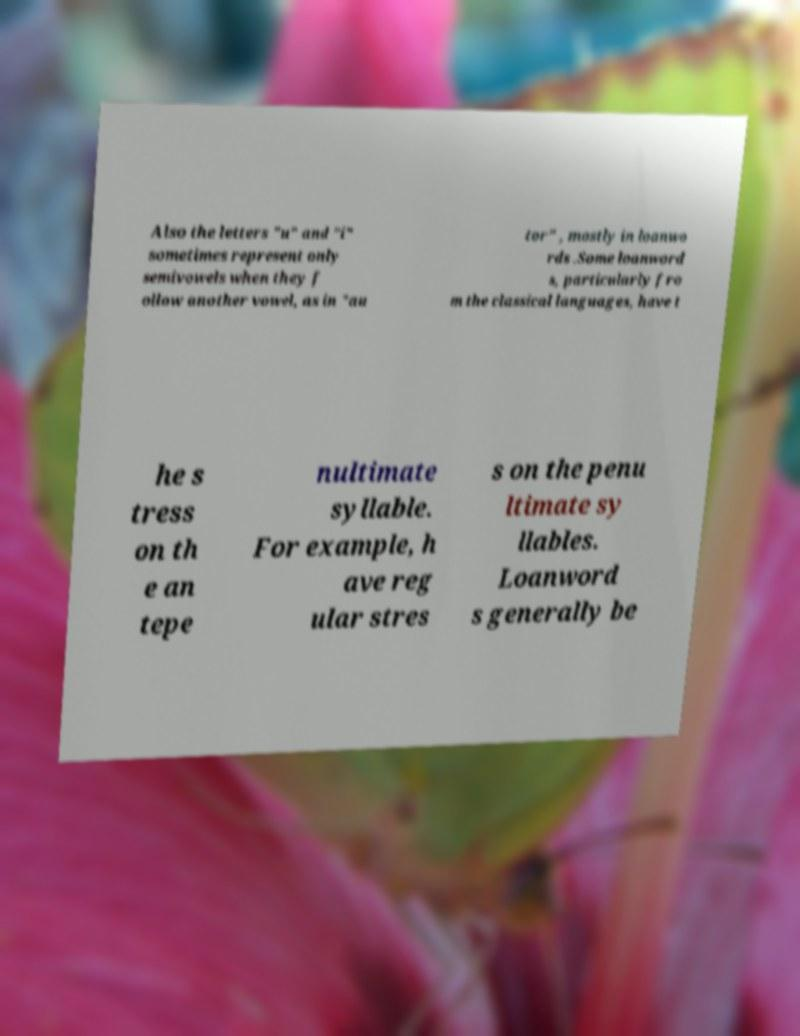Please read and relay the text visible in this image. What does it say? Also the letters "u" and "i" sometimes represent only semivowels when they f ollow another vowel, as in "au tor" , mostly in loanwo rds .Some loanword s, particularly fro m the classical languages, have t he s tress on th e an tepe nultimate syllable. For example, h ave reg ular stres s on the penu ltimate sy llables. Loanword s generally be 